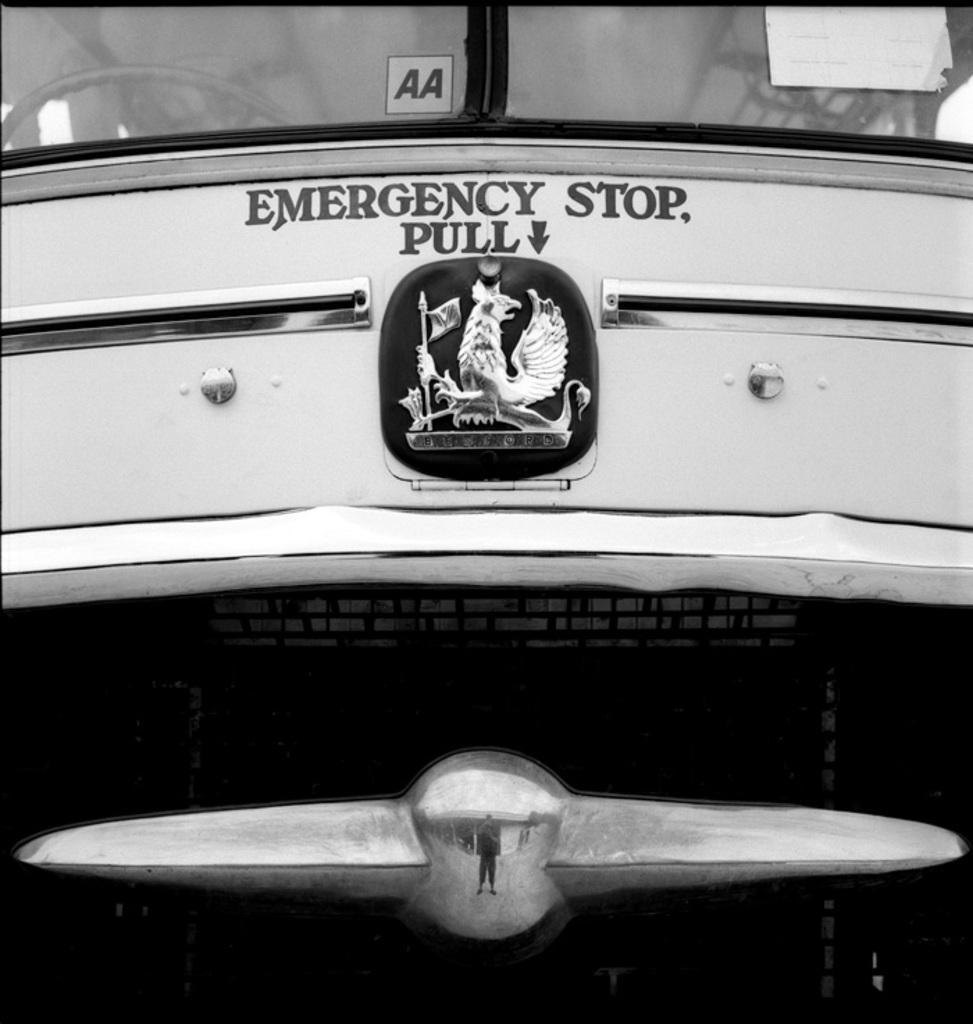<image>
Render a clear and concise summary of the photo. the front of a vehicle with a sign for an emergency stop pull 